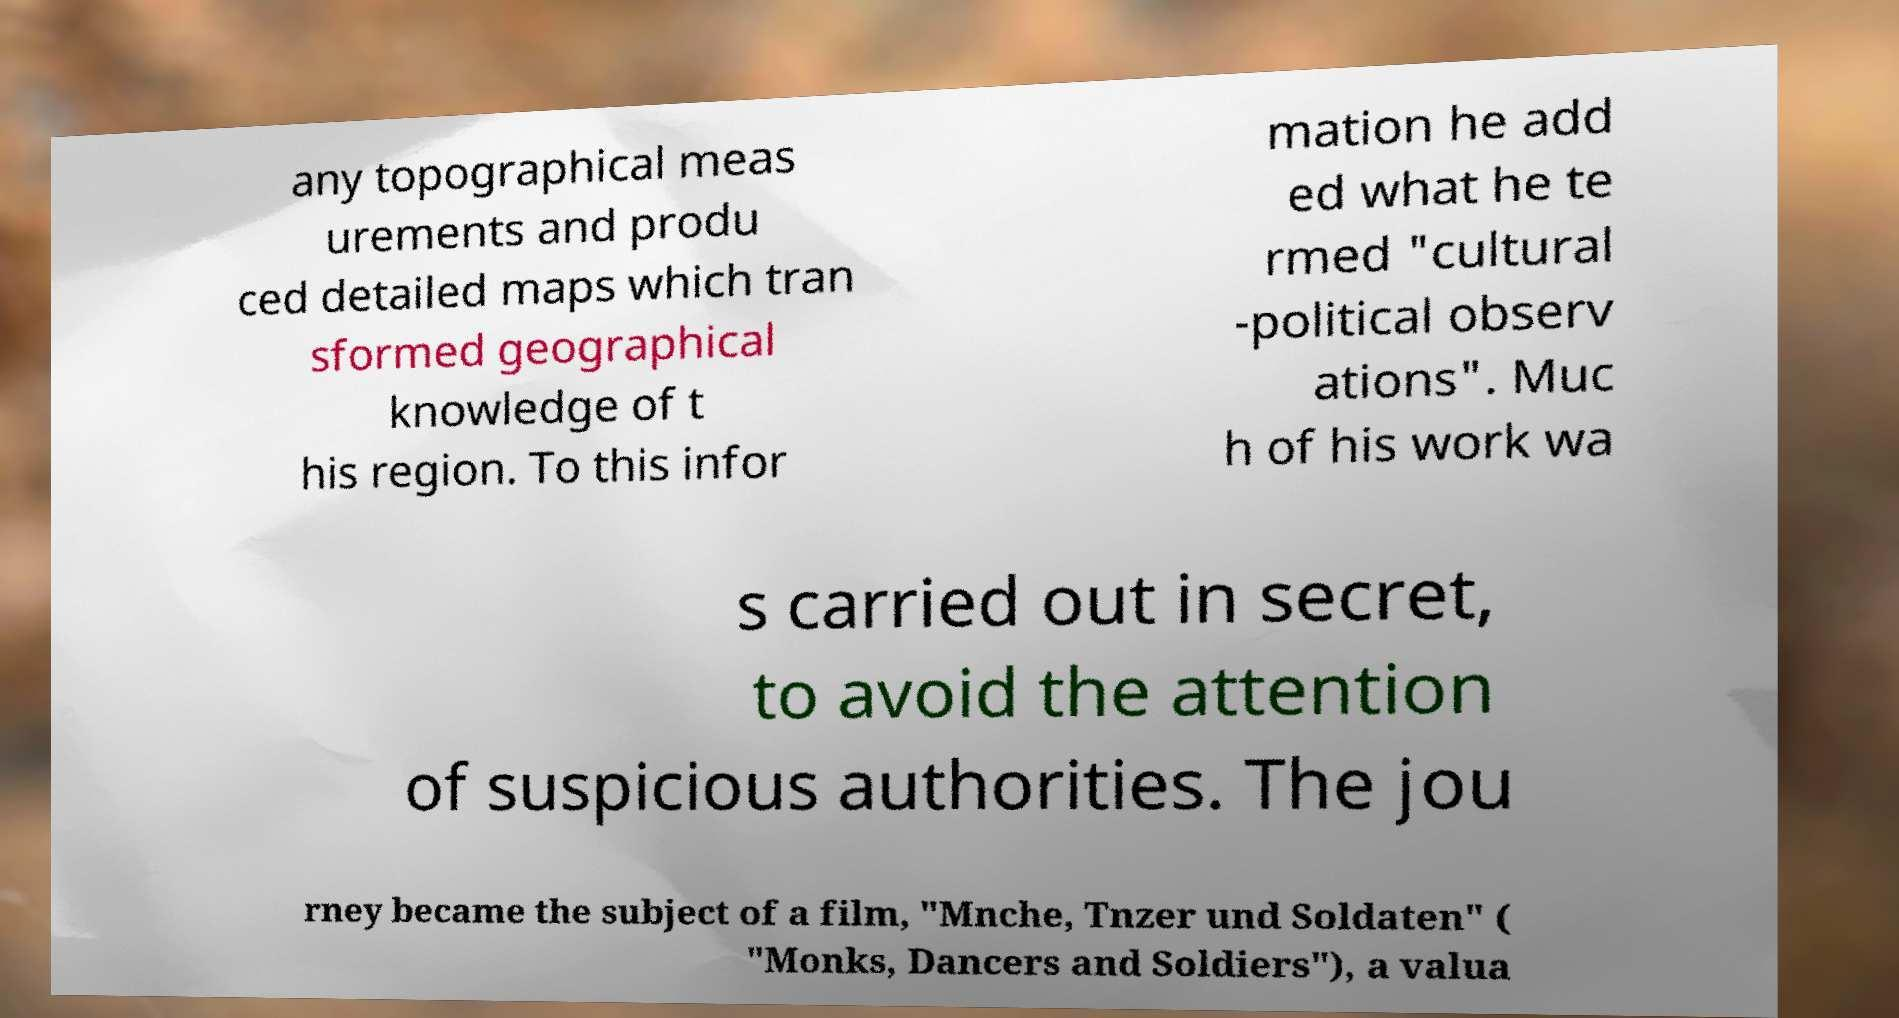There's text embedded in this image that I need extracted. Can you transcribe it verbatim? any topographical meas urements and produ ced detailed maps which tran sformed geographical knowledge of t his region. To this infor mation he add ed what he te rmed "cultural -political observ ations". Muc h of his work wa s carried out in secret, to avoid the attention of suspicious authorities. The jou rney became the subject of a film, "Mnche, Tnzer und Soldaten" ( "Monks, Dancers and Soldiers"), a valua 